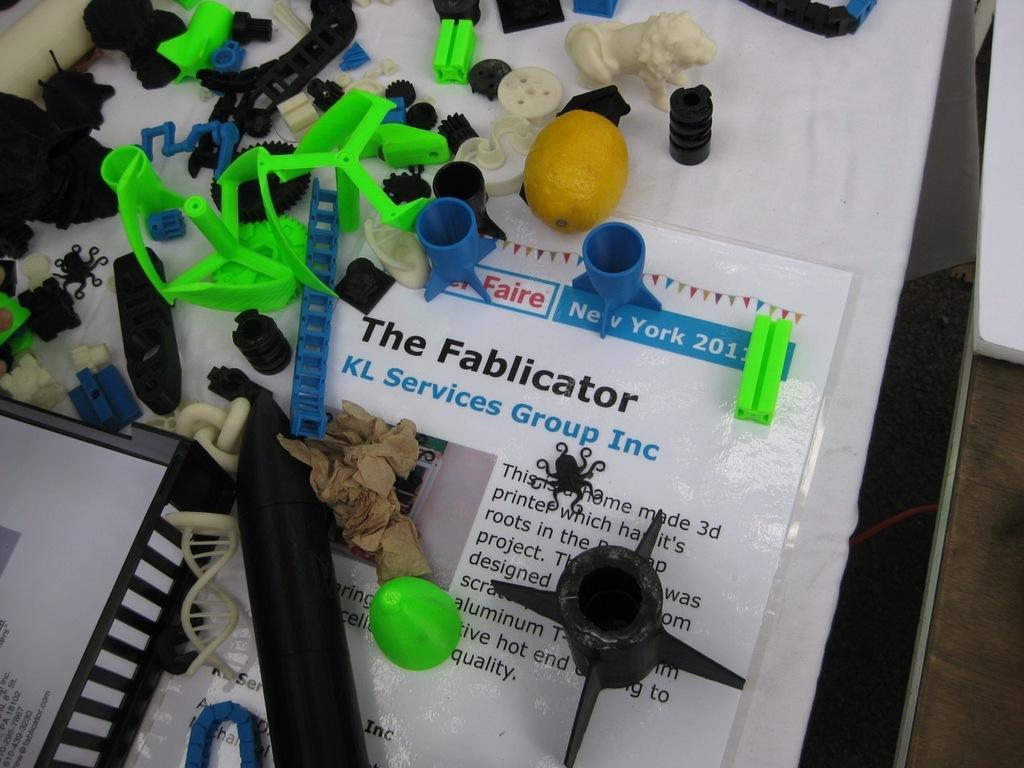Could you give a brief overview of what you see in this image? On the table I can see the paper, cloth, balls, lemon, toys, statue of a lion, caps and other objects. 